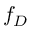Convert formula to latex. <formula><loc_0><loc_0><loc_500><loc_500>f _ { D }</formula> 